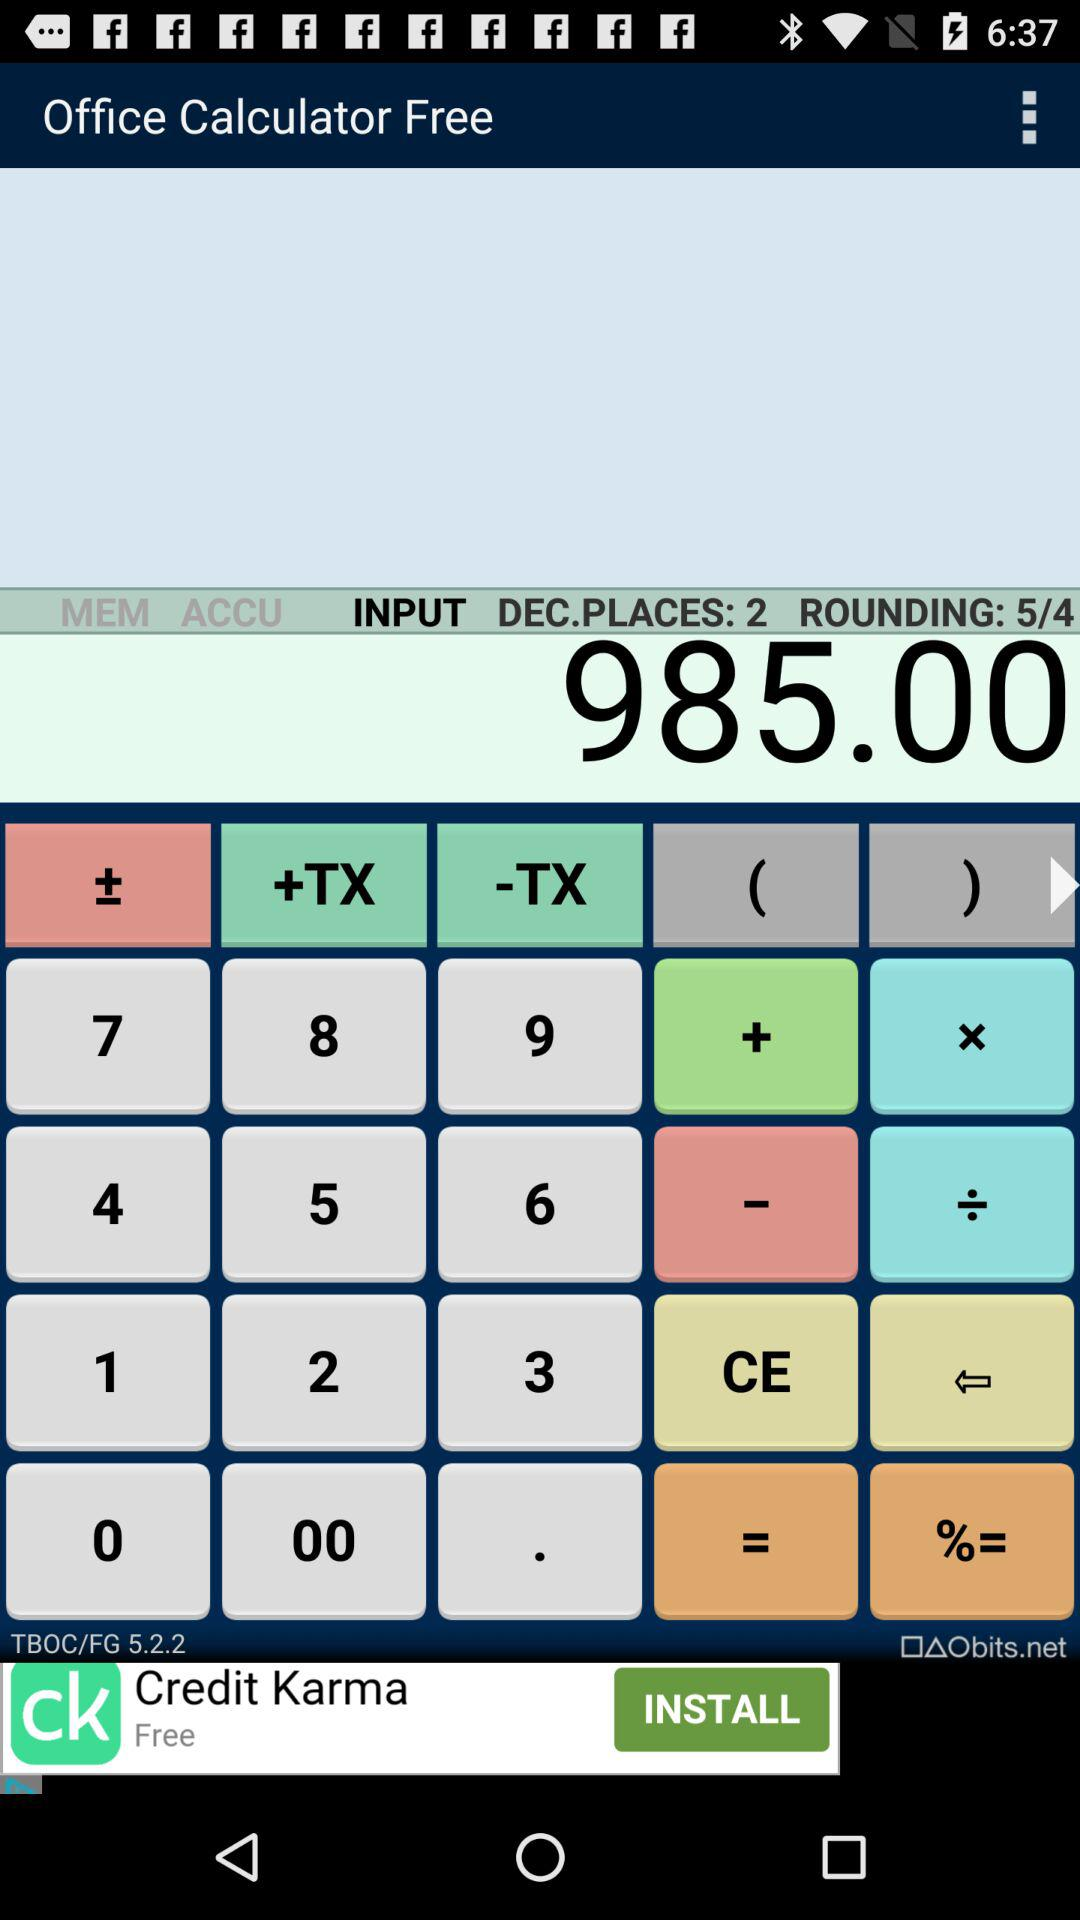What is the result? The result is 985.00. 